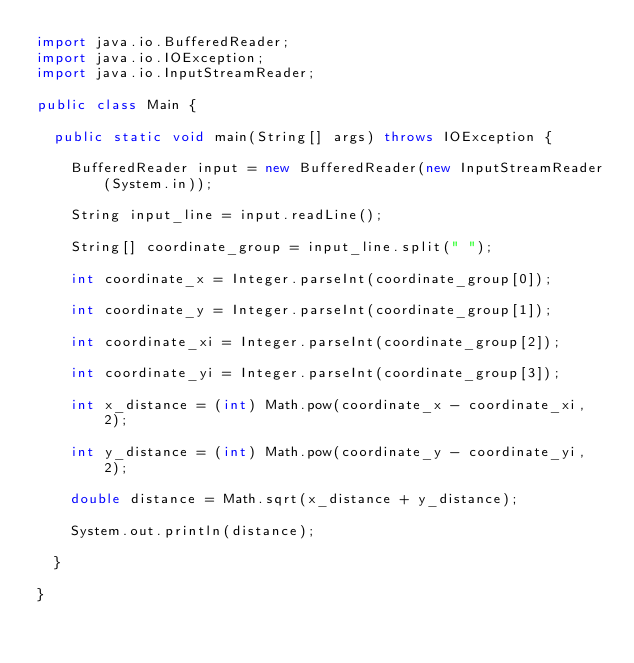<code> <loc_0><loc_0><loc_500><loc_500><_Java_>import java.io.BufferedReader;
import java.io.IOException;
import java.io.InputStreamReader;

public class Main {

	public static void main(String[] args) throws IOException {

		BufferedReader input = new BufferedReader(new InputStreamReader(System.in));

		String input_line = input.readLine();

		String[] coordinate_group = input_line.split(" ");

		int coordinate_x = Integer.parseInt(coordinate_group[0]);

		int coordinate_y = Integer.parseInt(coordinate_group[1]);

		int coordinate_xi = Integer.parseInt(coordinate_group[2]);

		int coordinate_yi = Integer.parseInt(coordinate_group[3]);

		int x_distance = (int) Math.pow(coordinate_x - coordinate_xi, 2);

		int y_distance = (int) Math.pow(coordinate_y - coordinate_yi, 2);

		double distance = Math.sqrt(x_distance + y_distance);

		System.out.println(distance);

	}

}</code> 